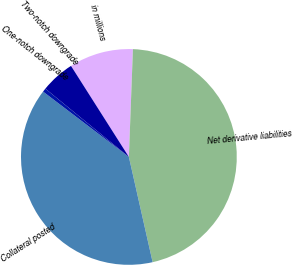<chart> <loc_0><loc_0><loc_500><loc_500><pie_chart><fcel>in millions<fcel>Net derivative liabilities<fcel>Collateral posted<fcel>One-notch downgrade<fcel>Two-notch downgrade<nl><fcel>9.61%<fcel>45.87%<fcel>38.89%<fcel>0.55%<fcel>5.08%<nl></chart> 